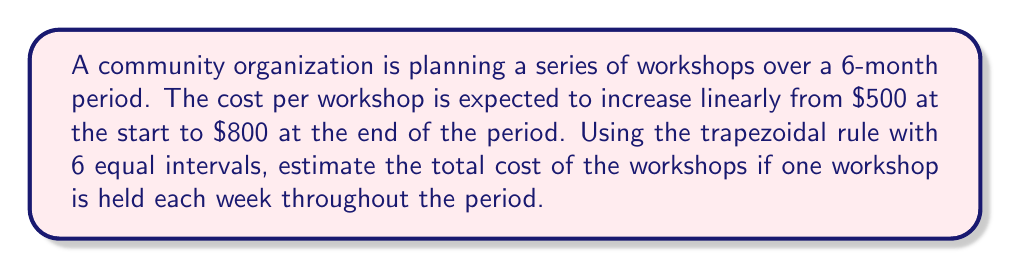Provide a solution to this math problem. To solve this problem, we'll use the trapezoidal rule for numerical integration. Here's the step-by-step process:

1) First, let's define our function. The cost is increasing linearly from $500 to $800 over 6 months. We can represent this as:

   $f(t) = 500 + 50t$, where $t$ is the time in months (0 ≤ t ≤ 6)

2) The trapezoidal rule formula for n intervals is:

   $$\int_{a}^{b} f(x) dx \approx \frac{h}{2}[f(x_0) + 2f(x_1) + 2f(x_2) + ... + 2f(x_{n-1}) + f(x_n)]$$

   where $h = \frac{b-a}{n}$

3) In our case, $a=0$, $b=6$, and $n=6$. So, $h = 1$ month.

4) Let's calculate the function values at each point:
   $f(0) = 500$
   $f(1) = 550$
   $f(2) = 600$
   $f(3) = 650$
   $f(4) = 700$
   $f(5) = 750$
   $f(6) = 800$

5) Applying the trapezoidal rule:

   $$\int_{0}^{6} f(t) dt \approx \frac{1}{2}[500 + 2(550 + 600 + 650 + 700 + 750) + 800]$$
   $$= \frac{1}{2}[500 + 2(3250) + 800]$$
   $$= \frac{1}{2}[7800] = 3900$$

6) This gives us the average cost over the 6-month period. To get the total cost, we need to multiply by the number of workshops. There are 26 weeks in 6 months, so:

   Total Cost = $3900 * 26 = 101,400$

Therefore, the estimated total cost of the workshops over the 6-month period is $101,400.
Answer: $101,400 